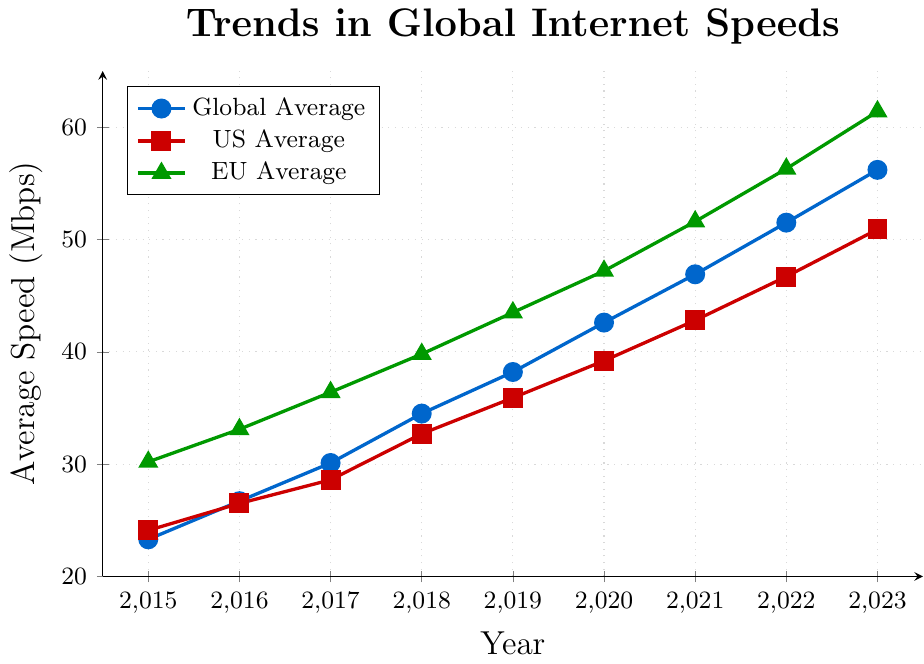What is the global average internet speed in 2019? Locate the year 2019 on the x-axis and find the corresponding point on the global average line (blue). The value is given at that point on the y-axis.
Answer: 38.2 Mbps How does the US average internet speed in 2017 compare to the EU average internet speed in the same year? Locate the year 2017 on the x-axis. Find the points for both the US (red) and EU (green) lines in that year. Compare the y-axis values for both points.
Answer: EU is higher In which year did the global average internet speed exceed 50 Mbps for the first time? Follow the global average line (blue) and identify the year where it first crosses above the 50 Mbps mark on the y-axis.
Answer: 2022 What is the approximate difference in internet speeds between the EU and US in 2023? Locate the year 2023 on the x-axis. Find the points for both the EU (green) and US (red) lines. Subtract the US value from the EU value (61.4 - 50.9).
Answer: 10.5 Mbps Between which years did the US average internet speed see the largest yearly increase? Examine the US average line (red). Calculate the yearly increases by subtracting the value of each year from the next. Find the largest difference. The largest increase occurred from 2022 to 2023 (50.9 - 46.7 = 4.2).
Answer: Between 2022 and 2023 How much did the global average internet speed change from 2015 to 2020? Locate the years 2015 and 2020 on the x-axis. Find the global average line (blue) values for these years. Subtract the 2015 value (23.3) from the 2020 value (42.6).
Answer: 19.3 Mbps Which region had the highest internet speed in 2020? Locate the year 2020 on the x-axis. Compare the values for the global (blue), US (red), and EU (green) lines in that year.
Answer: EU By how many Mbps did the US average internet speed increase between 2016 and 2017? Locate the years 2016 and 2017 on the x-axis. Find the US average line (red) values for these years. Subtract the 2016 value (26.5) from the 2017 value (28.6).
Answer: 2.1 Mbps What trend do you notice in the global average internet speed from 2015 to 2023? Observe the global average line (blue) from 2015 to 2023. The trend is the consistent upward movement of the line, indicating increasing internet speed.
Answer: Increasing trend 